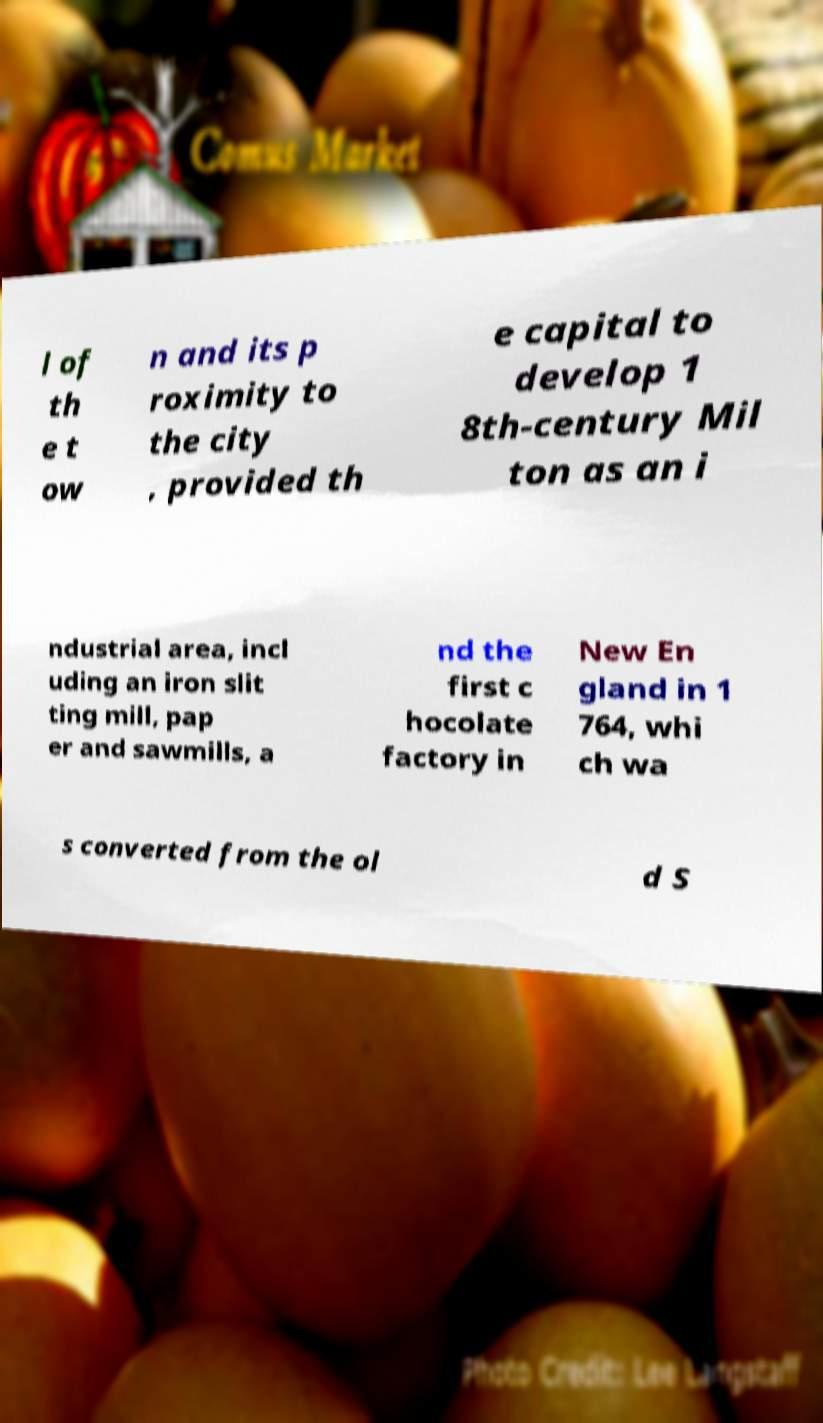Please identify and transcribe the text found in this image. l of th e t ow n and its p roximity to the city , provided th e capital to develop 1 8th-century Mil ton as an i ndustrial area, incl uding an iron slit ting mill, pap er and sawmills, a nd the first c hocolate factory in New En gland in 1 764, whi ch wa s converted from the ol d S 